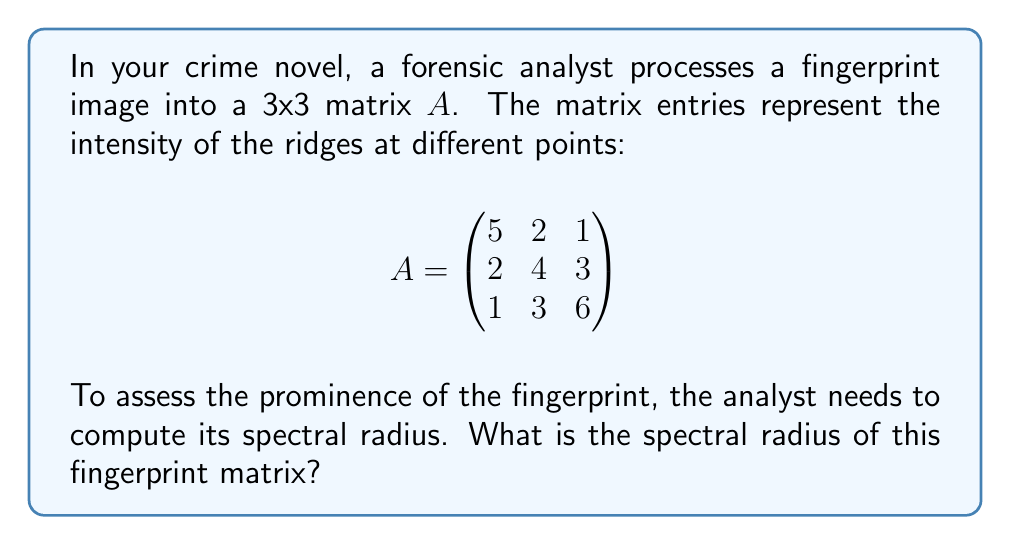Show me your answer to this math problem. To find the spectral radius of matrix $A$, we follow these steps:

1) The spectral radius is the largest absolute value of the eigenvalues of $A$.

2) To find the eigenvalues, we solve the characteristic equation:
   $\det(A - \lambda I) = 0$

3) Expanding the determinant:
   $$\begin{vmatrix}
   5-\lambda & 2 & 1 \\
   2 & 4-\lambda & 3 \\
   1 & 3 & 6-\lambda
   \end{vmatrix} = 0$$

4) This gives us the cubic equation:
   $-\lambda^3 + 15\lambda^2 - 59\lambda + 60 = 0$

5) Using the cubic formula or numerical methods, we find the roots:
   $\lambda_1 \approx 8.2915$
   $\lambda_2 \approx 4.5185$
   $\lambda_3 \approx 2.1900$

6) The spectral radius is the largest absolute value among these:
   $\rho(A) = |\lambda_1| \approx 8.2915$
Answer: $8.2915$ 